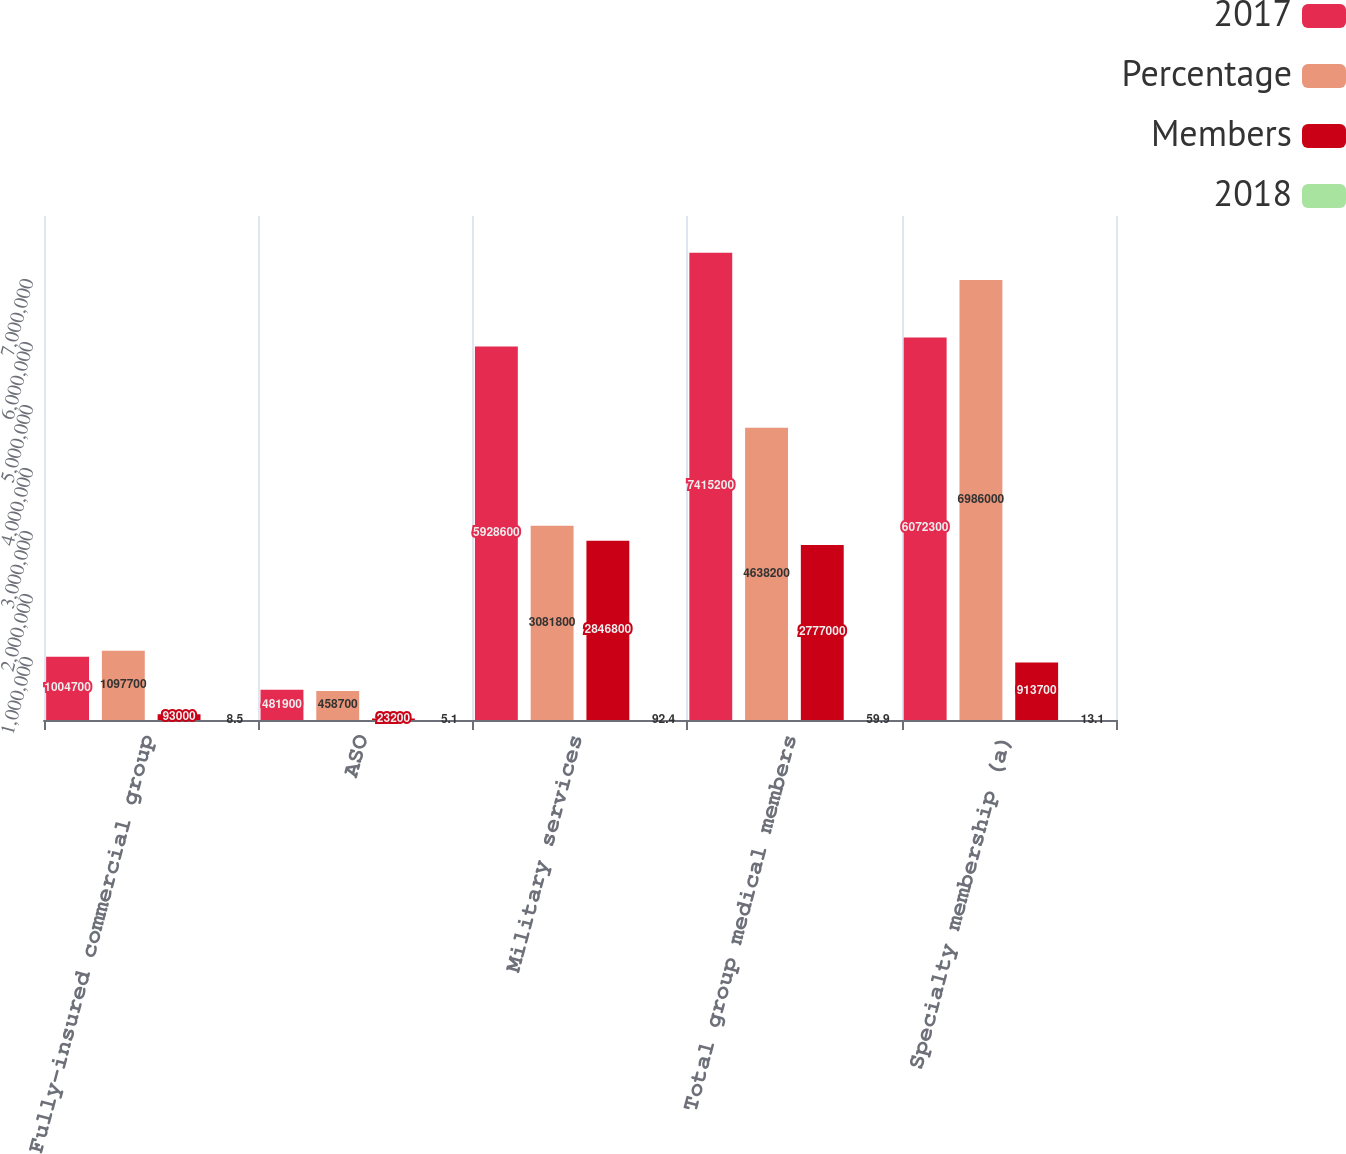Convert chart to OTSL. <chart><loc_0><loc_0><loc_500><loc_500><stacked_bar_chart><ecel><fcel>Fully-insured commercial group<fcel>ASO<fcel>Military services<fcel>Total group medical members<fcel>Specialty membership (a)<nl><fcel>2017<fcel>1.0047e+06<fcel>481900<fcel>5.9286e+06<fcel>7.4152e+06<fcel>6.0723e+06<nl><fcel>Percentage<fcel>1.0977e+06<fcel>458700<fcel>3.0818e+06<fcel>4.6382e+06<fcel>6.986e+06<nl><fcel>Members<fcel>93000<fcel>23200<fcel>2.8468e+06<fcel>2.777e+06<fcel>913700<nl><fcel>2018<fcel>8.5<fcel>5.1<fcel>92.4<fcel>59.9<fcel>13.1<nl></chart> 